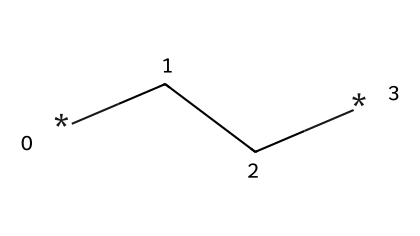What is the molecular formula represented by this SMILES? The SMILES representation *CC* indicates two carbon (C) atoms connected by a single bond. Thus, the molecular formula is C2H6, which includes 6 hydrogen atoms due to the tetravalent nature of carbon (each carbon can form four bonds).
Answer: C2H6 How many carbon atoms are present in this structure? By analyzing the SMILES *CC*, we can see that there are two carbon atoms represented in the sequence.
Answer: 2 What type of compound is represented by this chemical? The structure *CC* is an aliphatic compound because it contains carbon atoms connected in a straight or branched chain and does not contain any aromatic rings. Hence, it is categorized as an alkane.
Answer: alkane What is the degree of saturation in this compound? The formula for calculating the degree of saturation is based on the number of rings and pi bonds, which for alkanes is generally zero as they are fully saturated. Since this compound has no double bonds or rings in its structure, its degree of saturation is zero.
Answer: 0 How many hydrogen atoms are bonded to the carbons in this compound? In the aliphatic compound represented by *CC*, there are two carbon atoms that each bond to three hydrogen atoms, resulting in a total of six hydrogen atoms connected to the carbon backbone.
Answer: 6 Is this compound a gas, solid, or liquid at room temperature? Alkanes with low molecular weights (like C2H6) at room temperature are typically gases. Thus, due to its low molar mass, this compound is a gaseous state at standard conditions.
Answer: gas 